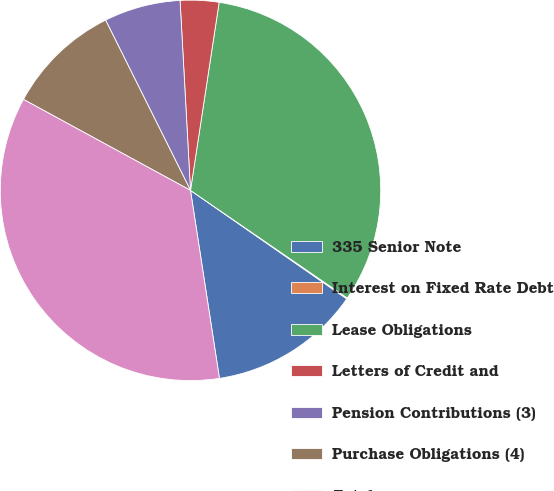Convert chart. <chart><loc_0><loc_0><loc_500><loc_500><pie_chart><fcel>335 Senior Note<fcel>Interest on Fixed Rate Debt<fcel>Lease Obligations<fcel>Letters of Credit and<fcel>Pension Contributions (3)<fcel>Purchase Obligations (4)<fcel>Total<nl><fcel>12.91%<fcel>0.08%<fcel>32.17%<fcel>3.28%<fcel>6.49%<fcel>9.7%<fcel>35.37%<nl></chart> 